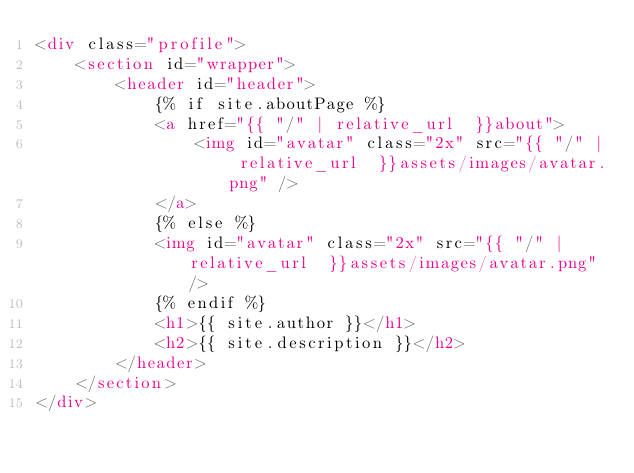<code> <loc_0><loc_0><loc_500><loc_500><_HTML_><div class="profile">
    <section id="wrapper">
        <header id="header">
            {% if site.aboutPage %}
            <a href="{{ "/" | relative_url  }}about">
                <img id="avatar" class="2x" src="{{ "/" | relative_url  }}assets/images/avatar.png" />
            </a>
            {% else %}
            <img id="avatar" class="2x" src="{{ "/" | relative_url  }}assets/images/avatar.png" />
            {% endif %}
            <h1>{{ site.author }}</h1>
            <h2>{{ site.description }}</h2>
        </header>
    </section>
</div></code> 